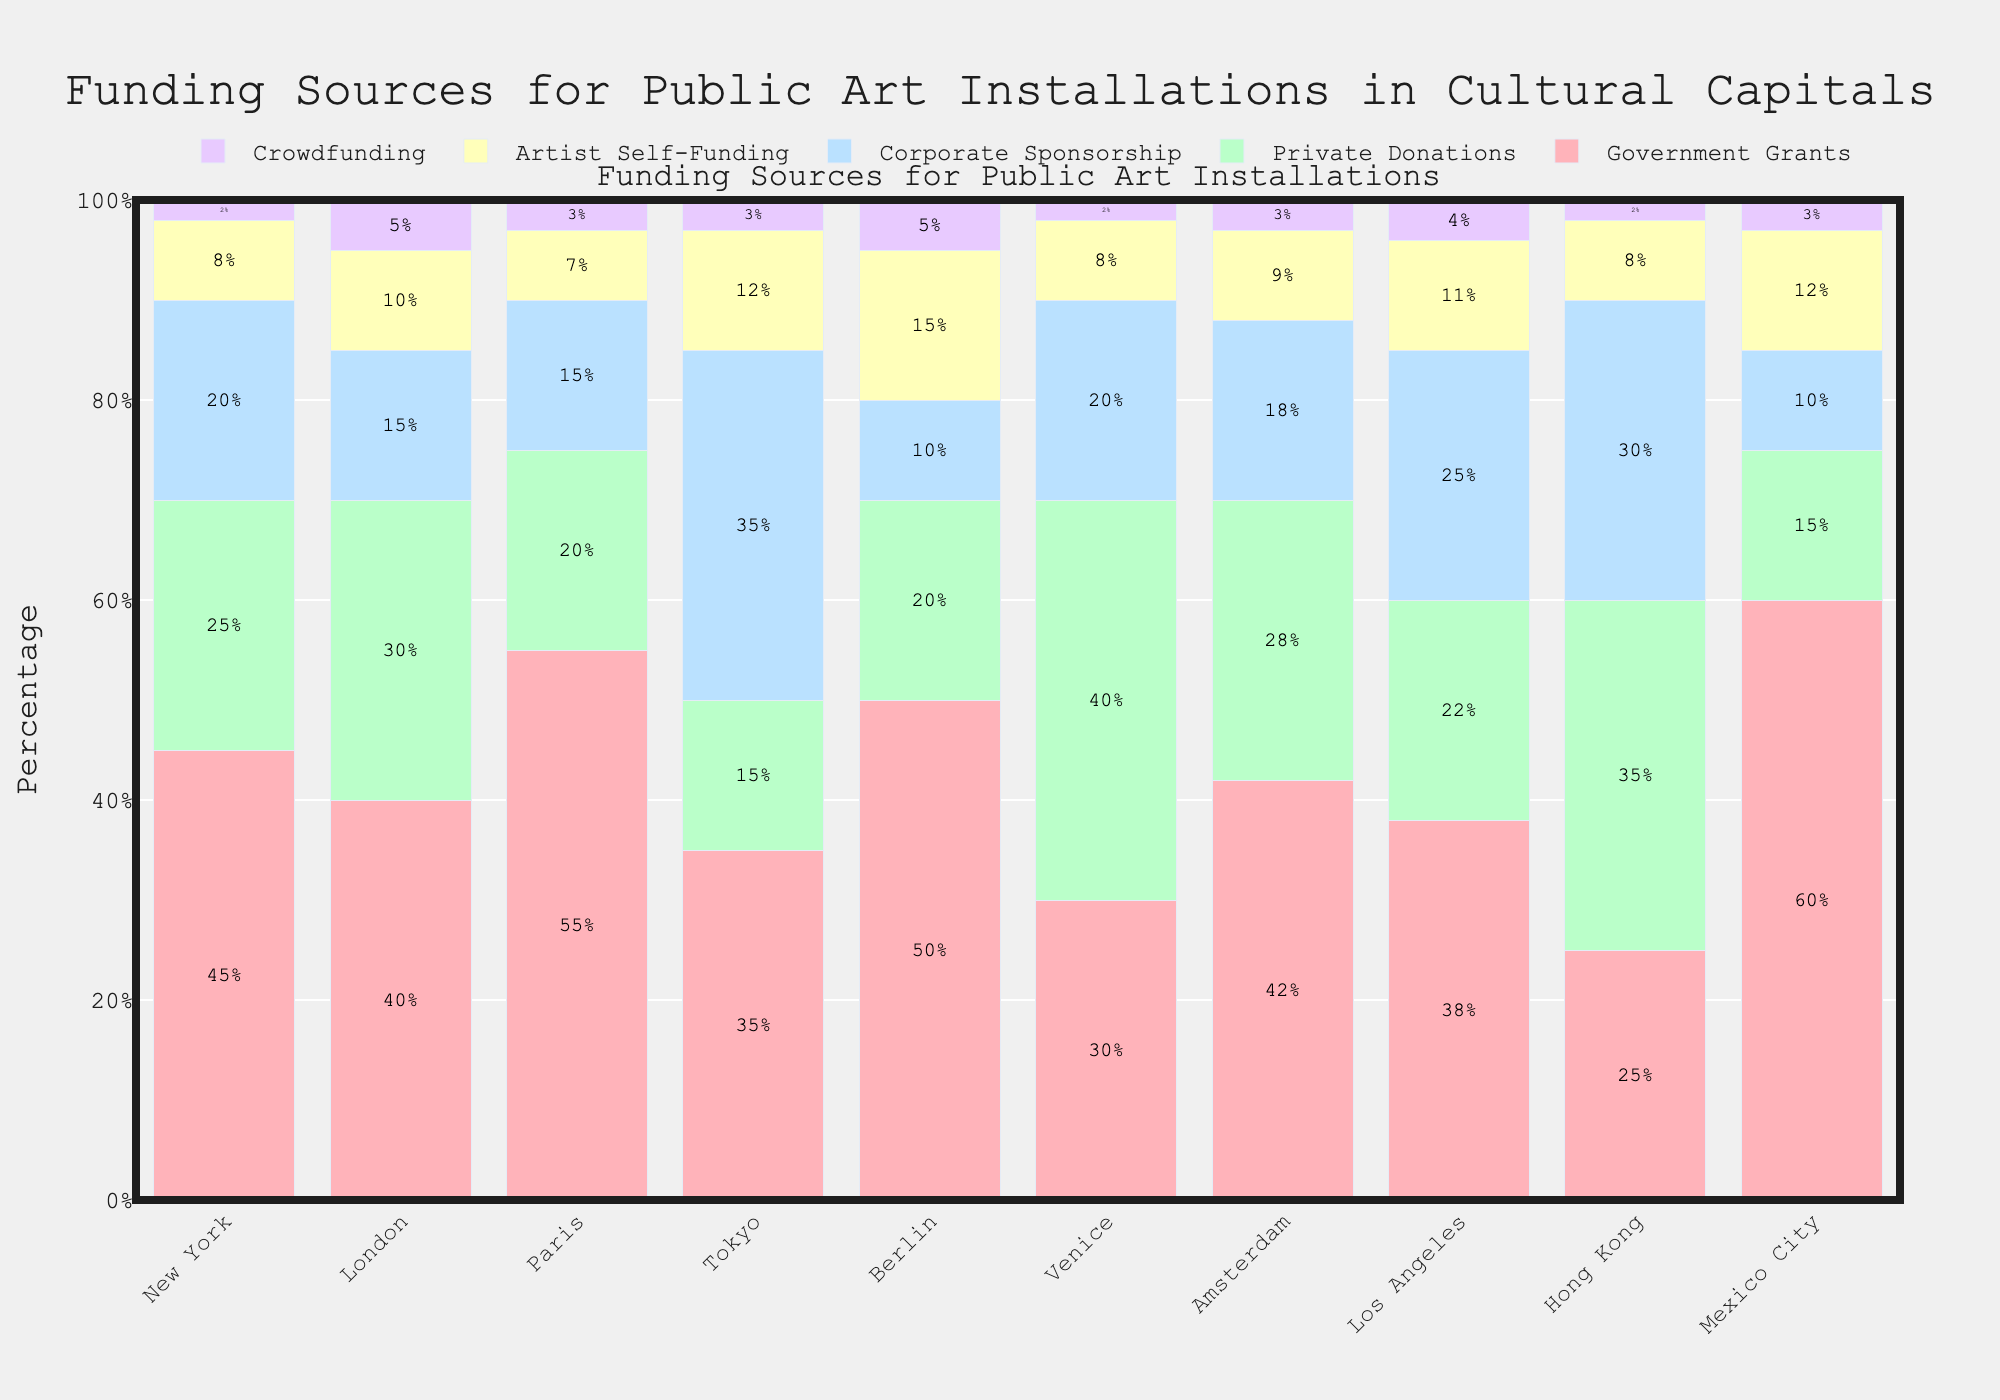What is the primary funding source for public art installations in Tokyo? The primary funding source is the segment with the largest proportion in Tokyo. In the bar corresponding to Tokyo, the largest segment is Corporate Sponsorship.
Answer: Corporate Sponsorship In which city does crowdfunding contribute the highest percentage? The city with the highest percentage of crowdfunding will have the tallest segment for Crowdfunding. In the bar chart, London and Berlin have the highest percentage of crowdfunding at 5%.
Answer: London and Berlin How does the government grants percentage in New York compare to that in Berlin? To compare the percentages, look at the height of the Government Grants segments for both cities. New York has a 45% government grant while Berlin has 50%.
Answer: Berlin has a higher percentage Which city has the highest percentage of private donations, and what is the value? The city with the tallest segment for Private Donations is the one with the highest percentage. Venice has the highest segment at 40%.
Answer: Venice at 40% What is the total percentage of Government Grants and Corporate Sponsorship in Paris? To find the total, add the percentages of Government Grants and Corporate Sponsorship in Paris. Government Grants is 55% and Corporate Sponsorship is 15%, so the total is 55 + 15 = 70%.
Answer: 70% Which funding source contributes the same percentage in both Los Angeles and Hong Kong? Look for the segments of equal height across both cities. In this case, Crowdfunding contributes 4% in Los Angeles and 2% in Hong Kong. We need to correct the earlier observation, so Private Donations contribute 22% in Los Angeles and 35% in Hong Kong. This leads to an amendment: None of the funding sources contribute the same exact percentage in both cities.
Answer: None Compare the percentage of Artist Self-Funding between Amsterdam and Mexico City. Check the height of the Artist Self-Funding segments for both cities. Amsterdam has 9% Artist Self-Funding, and Mexico City has 12%.
Answer: Mexico City has a higher percentage Which city has the least contribution from Crowdfunding, and what is the value? The city with the smallest segment for Crowdfunding has the least contribution. New York and Venice both have the smallest segments at 2%.
Answer: New York and Venice at 2% What is the combined percentage of all funding sources in London? The combined percentage is always 100% because the chart represents a breakdown of all funding sources for each city.
Answer: 100% In which city do private donations exceed government grants, and by how much? Identify cities where the Private Donations segment is taller than the Government Grants segment. In Venice, Private Donations (40%) exceed Government Grants (30%). The difference is 40 - 30 = 10%.
Answer: Venice by 10% 